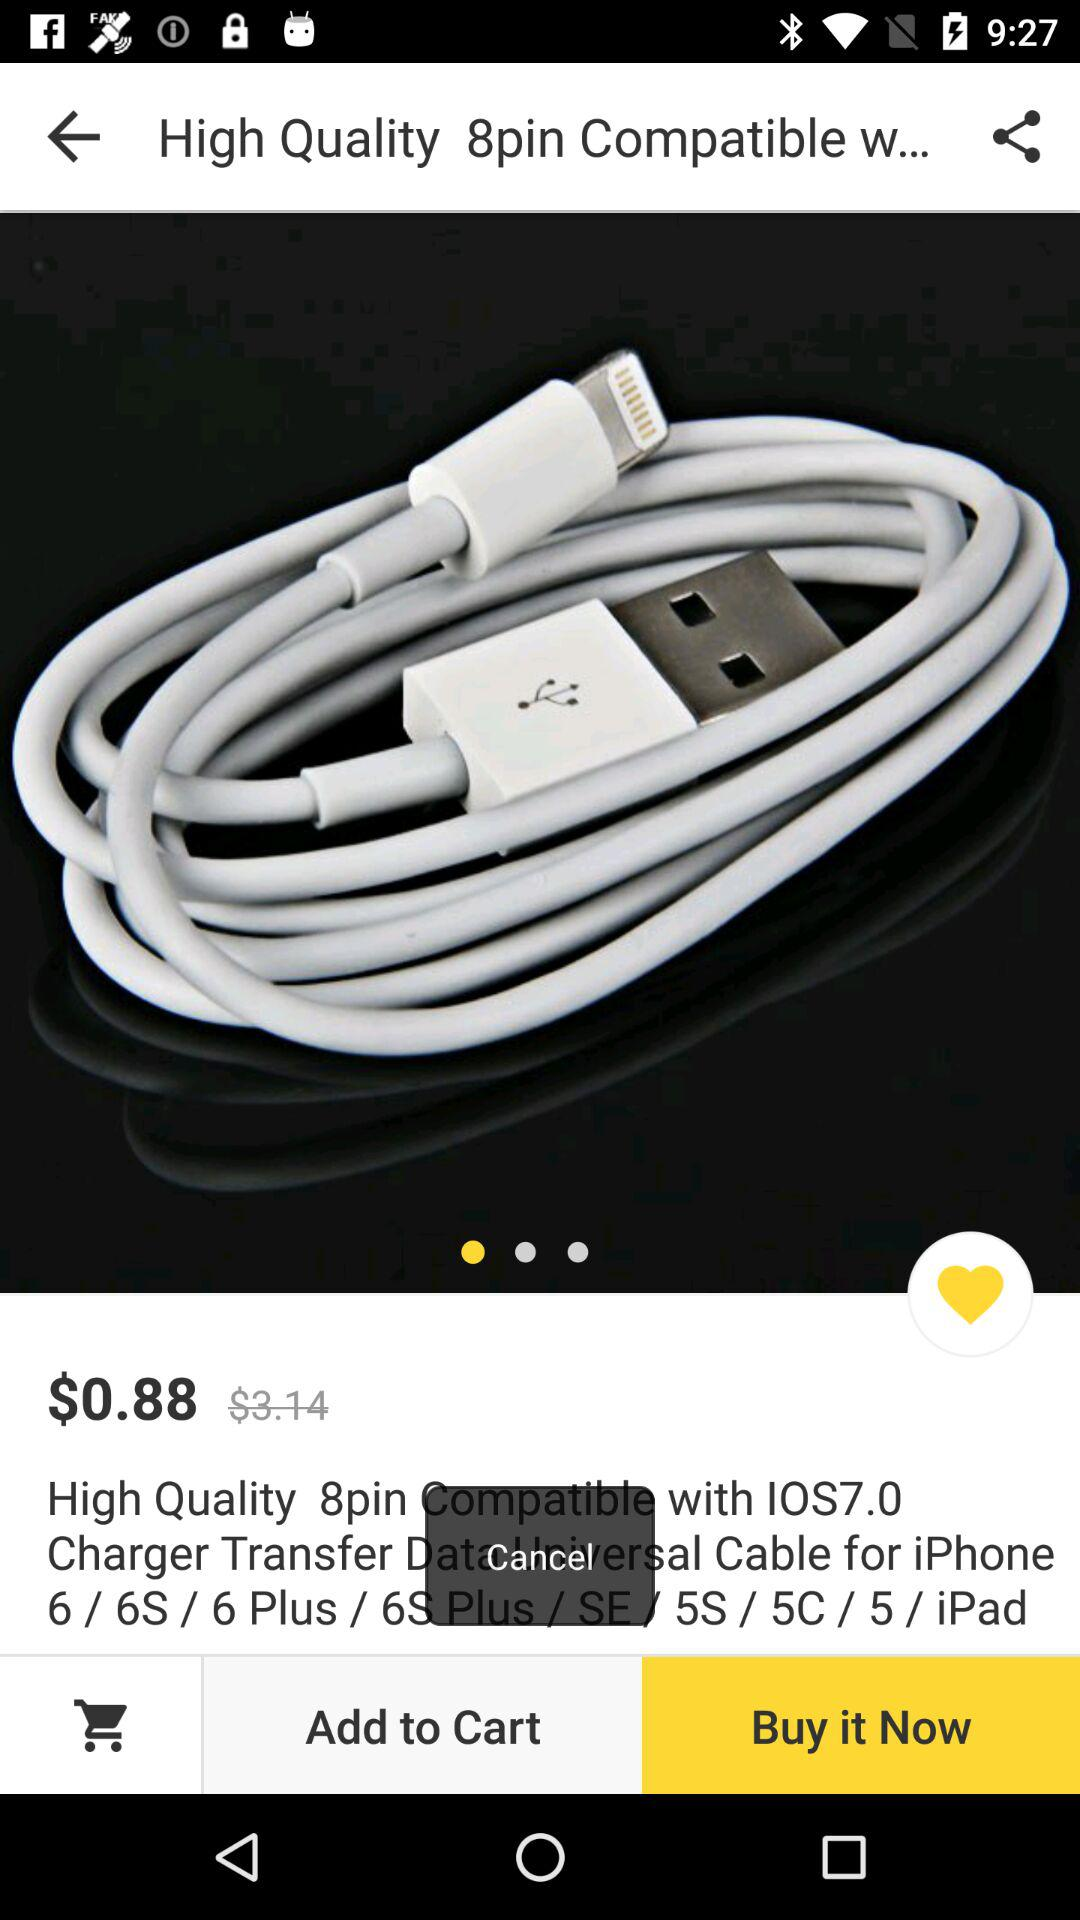What was the actual price of the data transfer cable? The actual price of the data transfer cable was $3.14. 